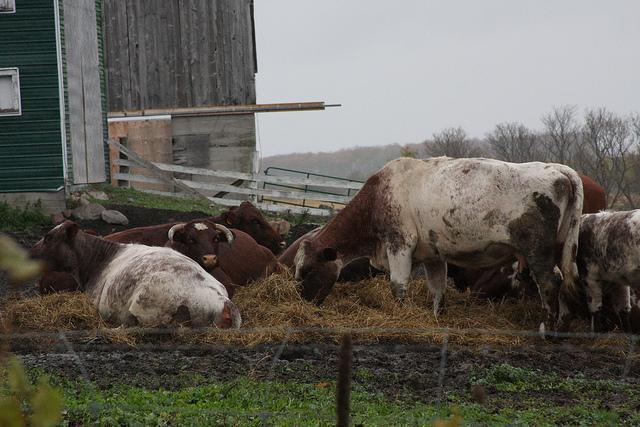How many cows are visible?
Give a very brief answer. 5. 